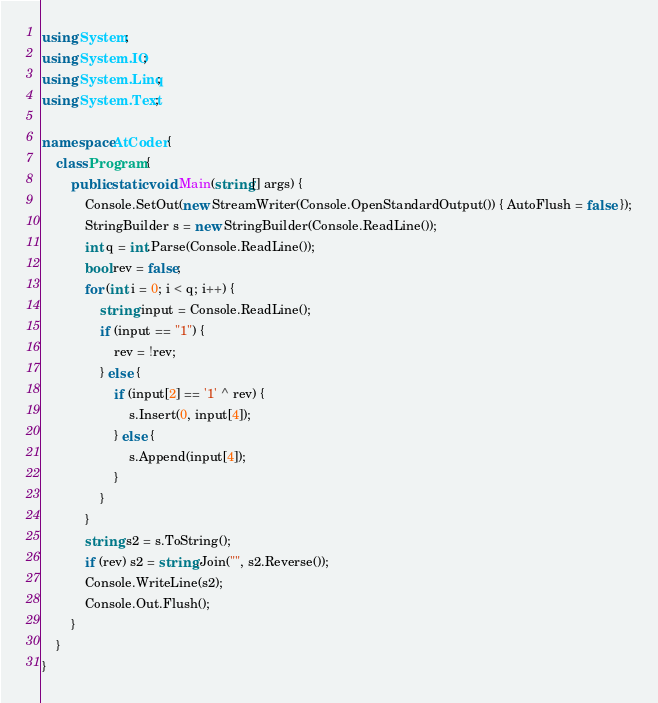<code> <loc_0><loc_0><loc_500><loc_500><_C#_>using System;
using System.IO;
using System.Linq;
using System.Text;

namespace AtCoder {
	class Program {
		public static void Main(string[] args) {
			Console.SetOut(new StreamWriter(Console.OpenStandardOutput()) { AutoFlush = false });
			StringBuilder s = new StringBuilder(Console.ReadLine());
			int q = int.Parse(Console.ReadLine());
			bool rev = false;
			for (int i = 0; i < q; i++) {
				string input = Console.ReadLine();
				if (input == "1") {
					rev = !rev;
				} else {
					if (input[2] == '1' ^ rev) {
						s.Insert(0, input[4]);
					} else {
						s.Append(input[4]);
					}
				}
			}
			string s2 = s.ToString();
			if (rev) s2 = string.Join("", s2.Reverse());
			Console.WriteLine(s2);
			Console.Out.Flush();
		}
	}
}
</code> 